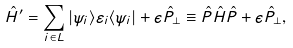Convert formula to latex. <formula><loc_0><loc_0><loc_500><loc_500>\hat { H } ^ { \prime } = \sum _ { i \in L } | \psi _ { i } \rangle \varepsilon _ { i } \langle \psi _ { i } | + \epsilon \hat { P } _ { \perp } \equiv \hat { P } \hat { H } \hat { P } + \epsilon \hat { P } _ { \perp } ,</formula> 